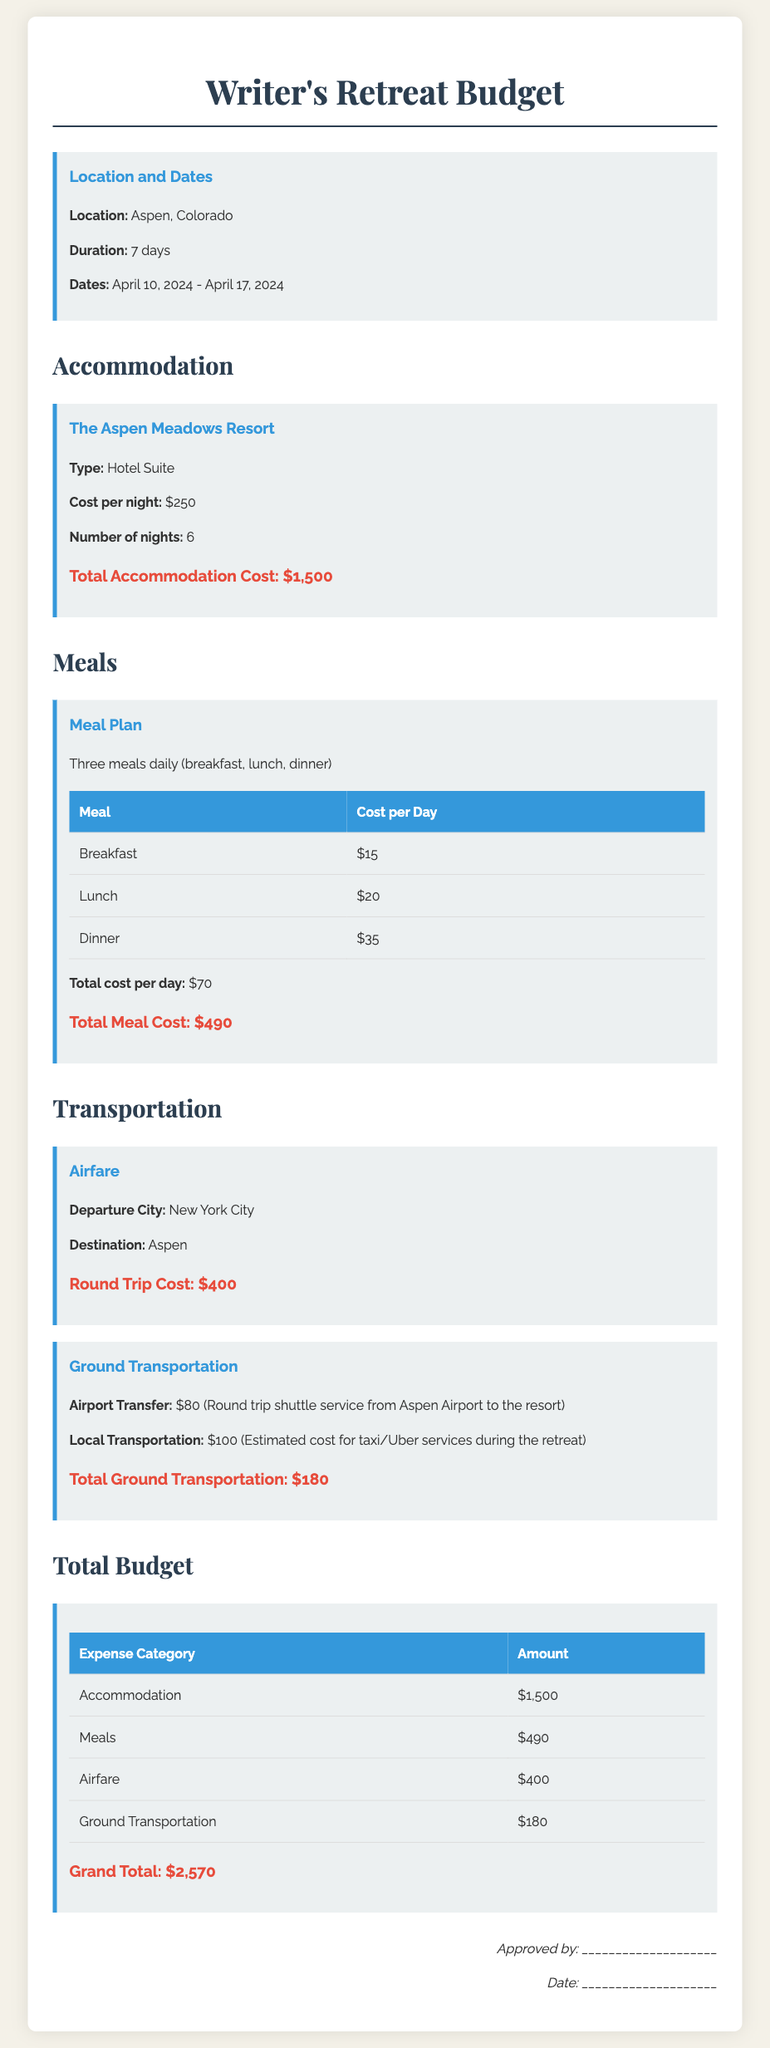What is the location of the retreat? The document specifies that the location of the retreat is Aspen, Colorado.
Answer: Aspen, Colorado What is the total accommodation cost? The total accommodation cost is calculated based on the number of nights and the cost per night, which is $250 per night for 6 nights.
Answer: $1,500 How many days does the retreat last? The duration of the retreat is explicitly mentioned in the document as 7 days.
Answer: 7 days What is the cost per day for meals? The cost per day for meals includes the costs for breakfast, lunch, and dinner, summing up to $70.
Answer: $70 What is the round trip airfare cost? The document reveals that the round trip airfare cost from New York City to Aspen is $400.
Answer: $400 What is the total cost of ground transportation? The ground transportation cost is specified as the sum of airport transfer and local transportation, totaling $180.
Answer: $180 What is the grand total for the retreat expenses? The grand total combines all expense categories, which is calculated as $2,570.
Answer: $2,570 What type of meal plan is included? The meal plan includes three meals daily: breakfast, lunch, and dinner.
Answer: Three meals daily What is the signature line for? The signature line is meant for approving the budget, indicating who approved it and the date of approval.
Answer: Approval signature 